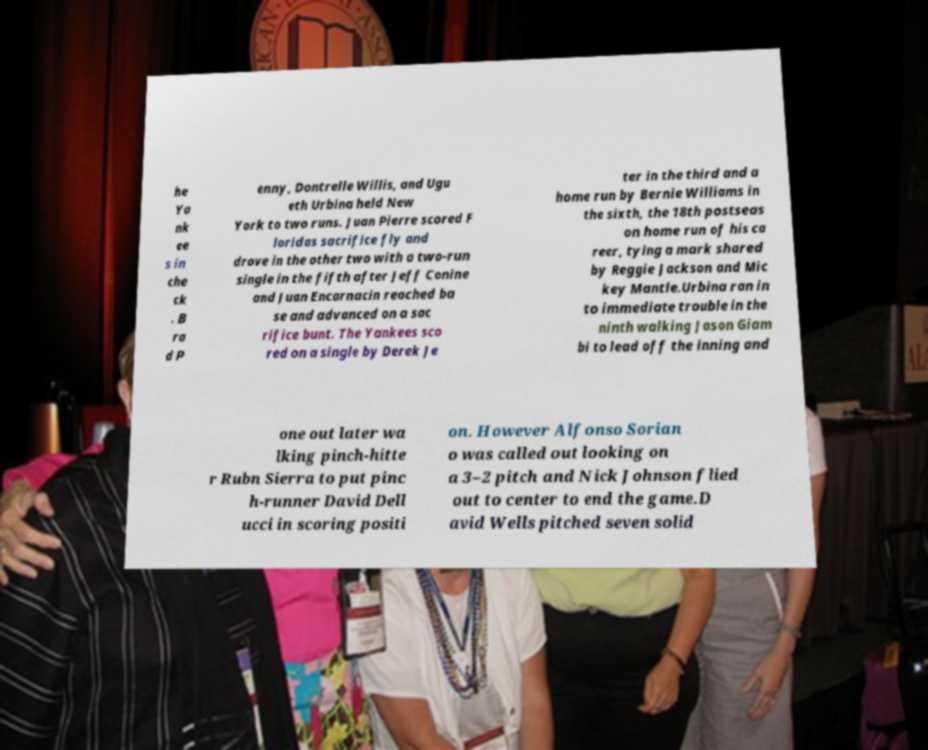I need the written content from this picture converted into text. Can you do that? he Ya nk ee s in che ck . B ra d P enny, Dontrelle Willis, and Ugu eth Urbina held New York to two runs. Juan Pierre scored F loridas sacrifice fly and drove in the other two with a two-run single in the fifth after Jeff Conine and Juan Encarnacin reached ba se and advanced on a sac rifice bunt. The Yankees sco red on a single by Derek Je ter in the third and a home run by Bernie Williams in the sixth, the 18th postseas on home run of his ca reer, tying a mark shared by Reggie Jackson and Mic key Mantle.Urbina ran in to immediate trouble in the ninth walking Jason Giam bi to lead off the inning and one out later wa lking pinch-hitte r Rubn Sierra to put pinc h-runner David Dell ucci in scoring positi on. However Alfonso Sorian o was called out looking on a 3–2 pitch and Nick Johnson flied out to center to end the game.D avid Wells pitched seven solid 